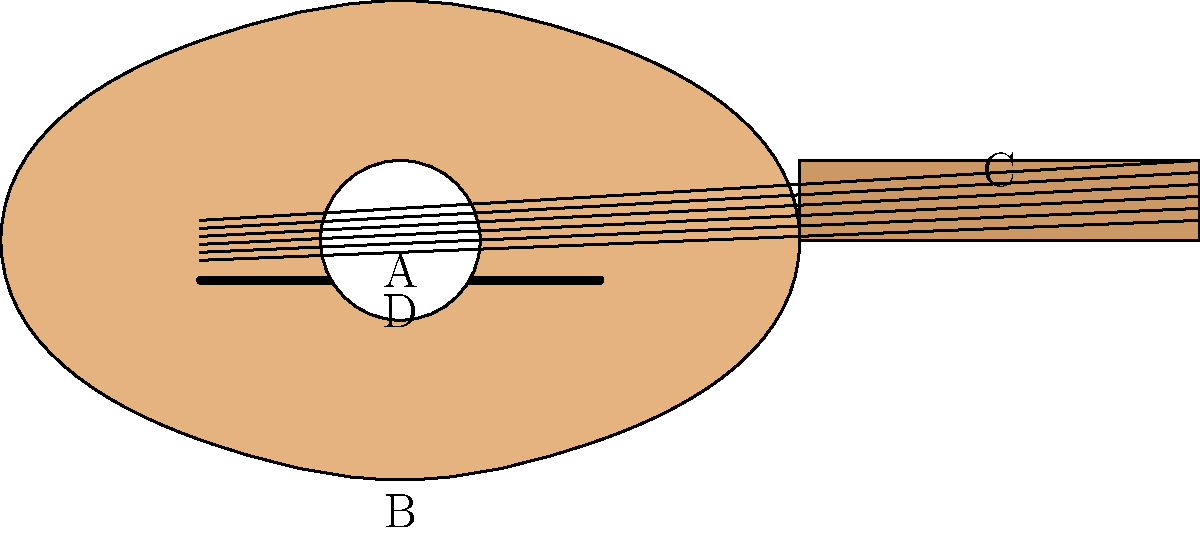In the acoustic guitar diagram, what is the part labeled "A"? To answer this question, let's look at the different parts of the acoustic guitar in the diagram:

1. The large hollow body of the guitar is shown at the bottom of the image.
2. The long, narrow part extending from the body is the neck of the guitar.
3. At the bottom of the body, there's a horizontal line representing the bridge.
4. In the center of the body, there's a circular opening.

The part labeled "A" is pointing to this circular opening in the center of the guitar's body. This opening is called the sound hole. It serves an important function in acoustic guitars:

1. It allows the sound from the vibrating strings to project out of the guitar's body.
2. It contributes to the resonance and overall tone of the instrument.
3. It helps to amplify the sound naturally, without the need for electronic amplification.

The sound hole is a distinctive feature of acoustic guitars and is crucial for their characteristic sound.
Answer: Sound hole 